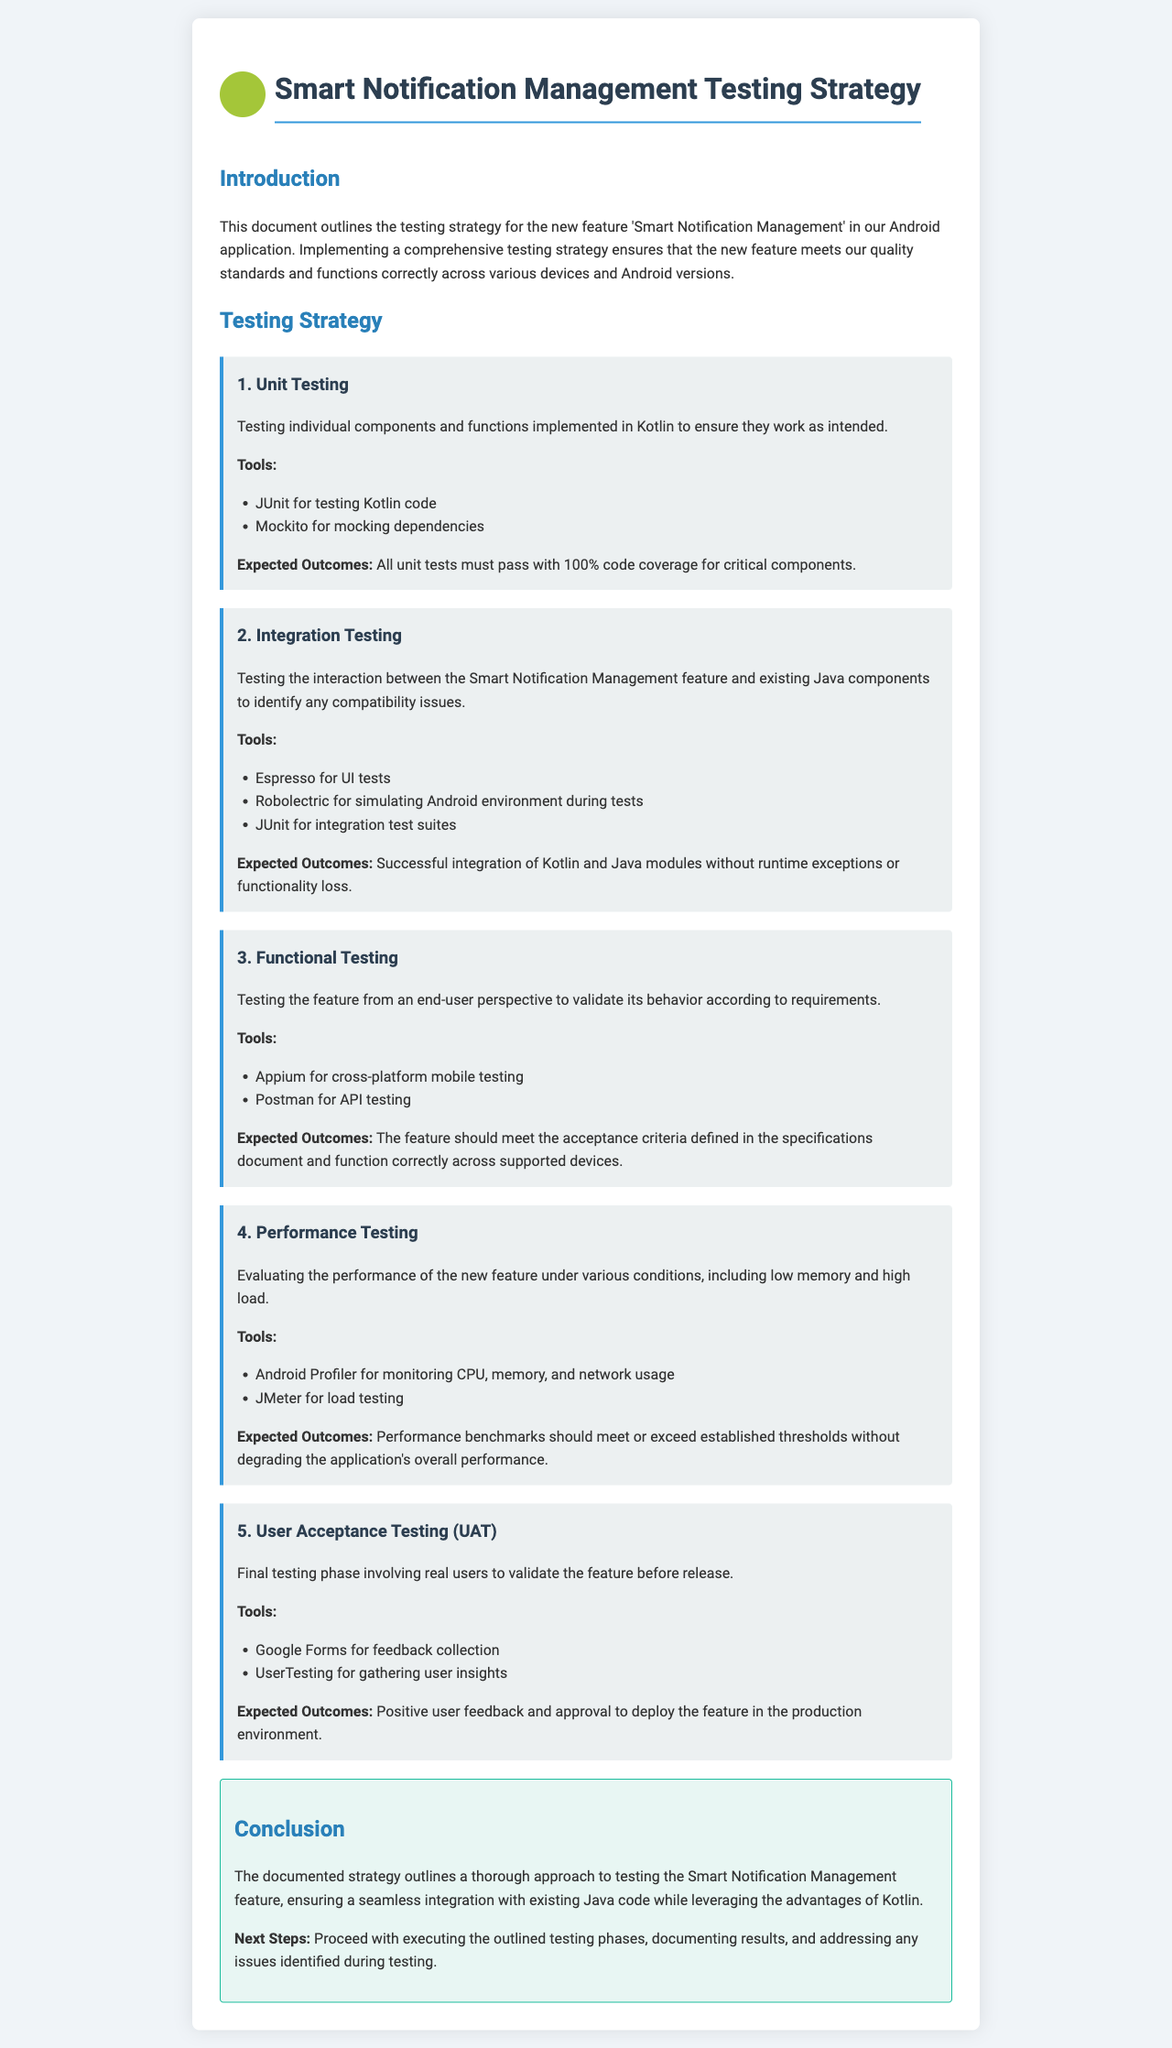what is the title of the document? The title of the document is stated in the header section.
Answer: Smart Notification Management Testing Strategy how many testing phases are outlined in the document? The document clearly lists the phases in the testing strategy section.
Answer: 5 which tool is used for unit testing Kotlin code? The unit testing phase specifies the tools used for testing.
Answer: JUnit what is the expected outcome for integration testing? The expected outcome is described in the integration testing phase.
Answer: Successful integration of Kotlin and Java modules without runtime exceptions or functionality loss what tool is mentioned for performance testing? The performance testing phase lists the tools used for evaluation.
Answer: Android Profiler what kind of testing does User Acceptance Testing (UAT) involve? The document states the focus of the final testing phase at the end of the document.
Answer: Real users 